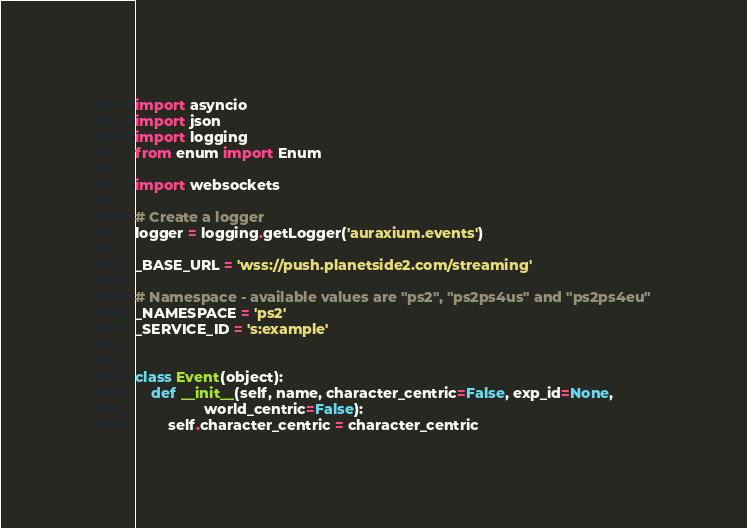<code> <loc_0><loc_0><loc_500><loc_500><_Python_>import asyncio
import json
import logging
from enum import Enum

import websockets

# Create a logger
logger = logging.getLogger('auraxium.events')

_BASE_URL = 'wss://push.planetside2.com/streaming'

# Namespace - available values are "ps2", "ps2ps4us" and "ps2ps4eu"
_NAMESPACE = 'ps2'
_SERVICE_ID = 's:example'


class Event(object):
    def __init__(self, name, character_centric=False, exp_id=None,
                 world_centric=False):
        self.character_centric = character_centric</code> 